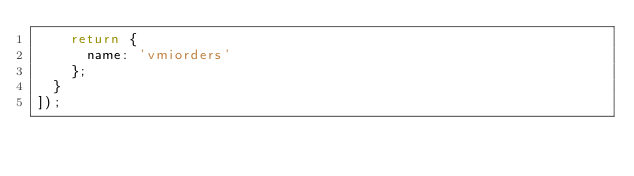<code> <loc_0><loc_0><loc_500><loc_500><_JavaScript_>    return {
      name: 'vmiorders'
    };
  }
]);
</code> 